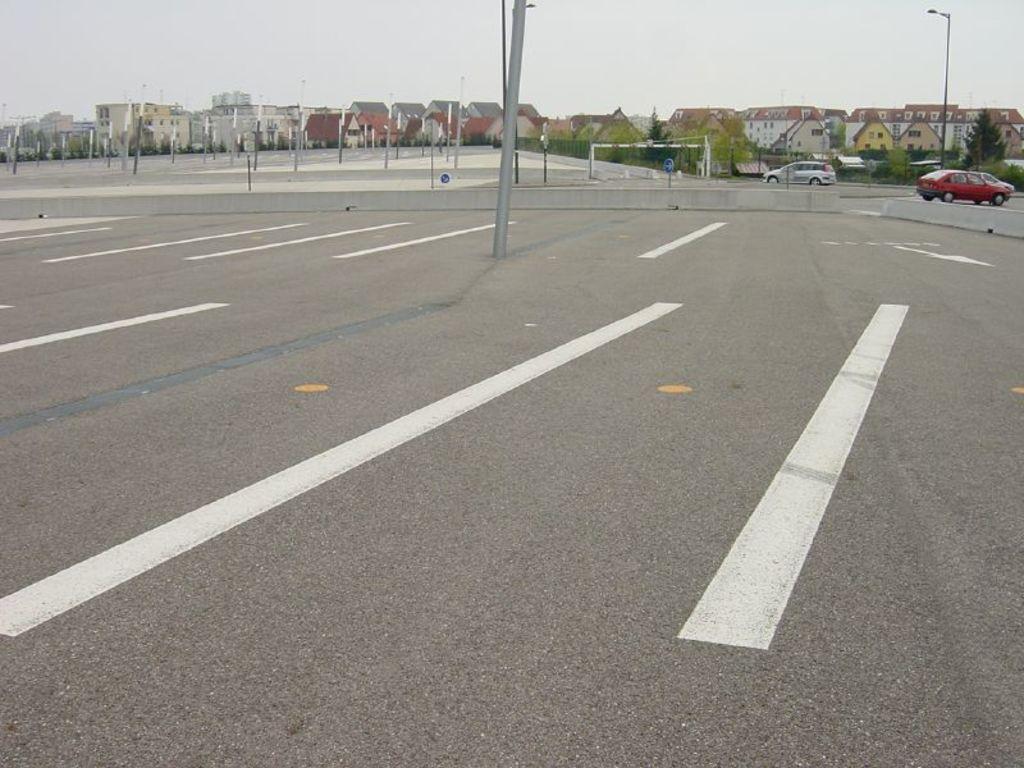In one or two sentences, can you explain what this image depicts? In this image we can see a parking area with a pole. Near to that there is a small sidewall. In the back there are vehicles, poles, trees, buildings and sky. In the background there is sky. Also there is a light pole. 